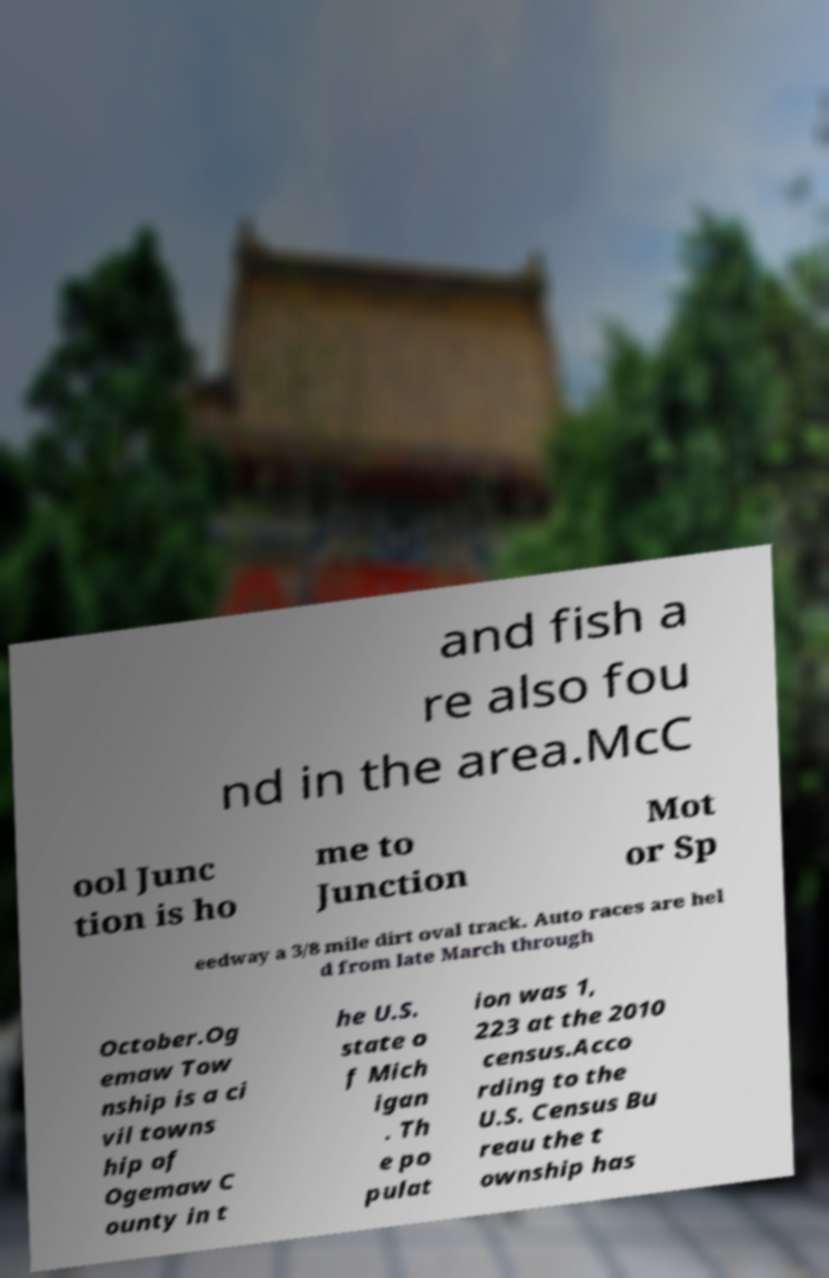Can you accurately transcribe the text from the provided image for me? and fish a re also fou nd in the area.McC ool Junc tion is ho me to Junction Mot or Sp eedway a 3/8 mile dirt oval track. Auto races are hel d from late March through October.Og emaw Tow nship is a ci vil towns hip of Ogemaw C ounty in t he U.S. state o f Mich igan . Th e po pulat ion was 1, 223 at the 2010 census.Acco rding to the U.S. Census Bu reau the t ownship has 